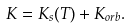Convert formula to latex. <formula><loc_0><loc_0><loc_500><loc_500>K = K _ { s } ( T ) + K _ { o r b } .</formula> 